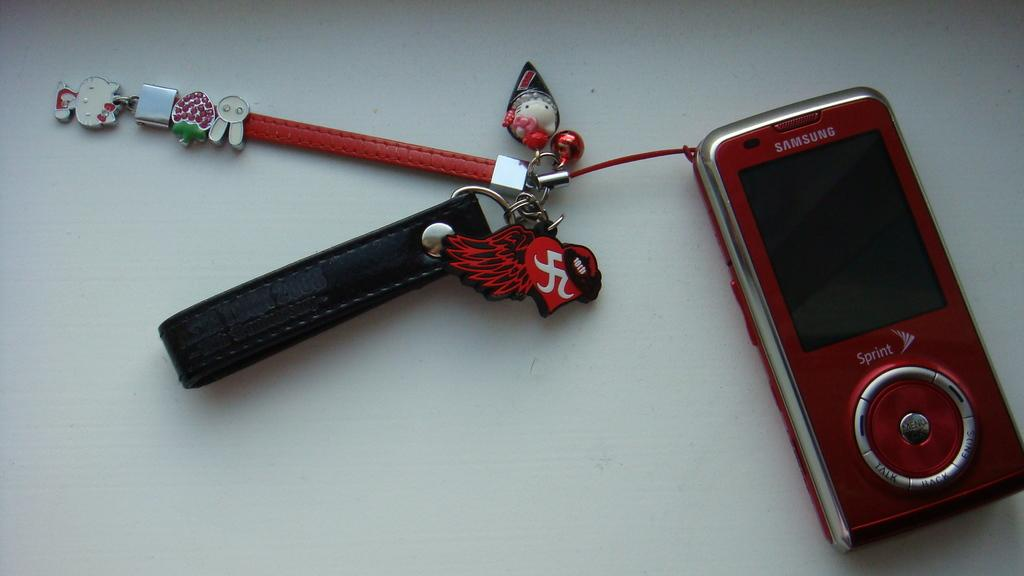What is the main object in the image? There is a mobile in the image. What other items can be seen in the image? There are keychains in the image. What is the color of the surface on which the mobile and keychains are placed? The mobile and keychains are on a white surface. What flavor of ice cream is being prepared in the oven in the image? There is no ice cream or oven present in the image. What type of frame is surrounding the mobile in the image? There is no frame surrounding the mobile in the image. 